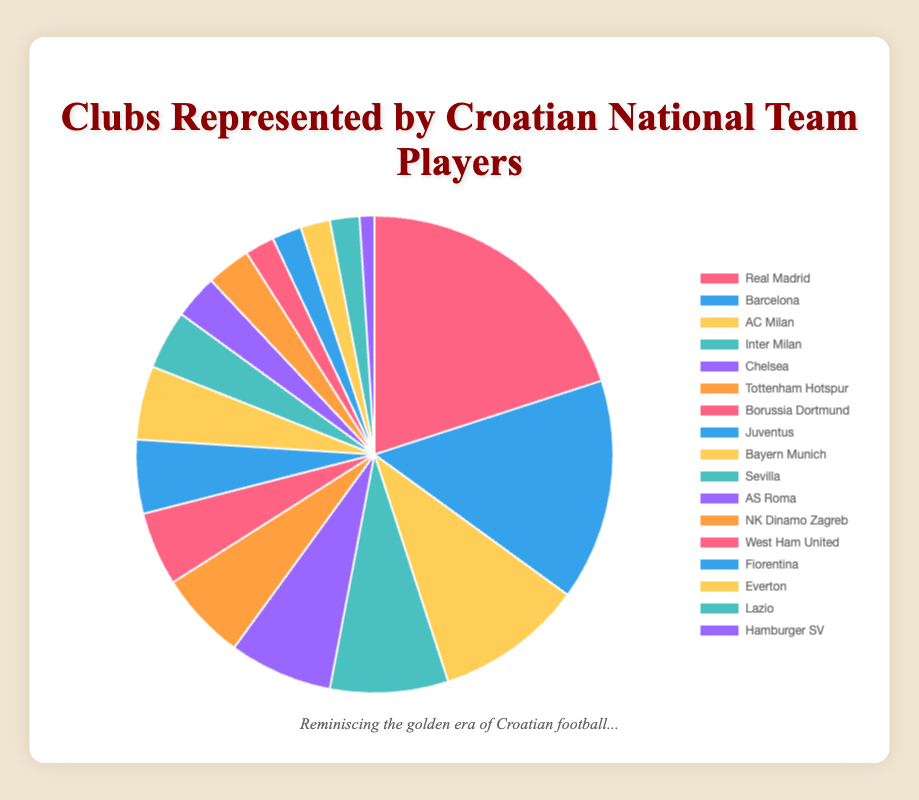Which club has the highest percentage of Croatian national team players during their peak? The pie chart shows that Real Madrid has the highest percentage, with 20%.
Answer: Real Madrid What's the difference in percentage between players who were at Real Madrid and those at Barcelona during their peak? Real Madrid has 20%, and Barcelona has 15%. The difference is 20% - 15% = 5%.
Answer: 5% How many clubs have a representation of 5% or more? The clubs with representation of 5% or more are Real Madrid (20%), Barcelona (15%), AC Milan (10%), Inter Milan (8%), Chelsea (7%), Tottenham Hotspur (6%), Borussia Dortmund (5%), Juventus (5%), and Bayern Munich (5%). There are 9 in total.
Answer: 9 Which clubs have an equal percentage of 5%? Borussia Dortmund, Juventus, and Bayern Munich each have a percentage of 5%.
Answer: Borussia Dortmund, Juventus, Bayern Munich If you combine the percentages of AC Milan and Inter Milan, do they surpass the percentage of Real Madrid? AC Milan has 10%, and Inter Milan has 8%. Combining them gives 10% + 8% = 18%, which is less than 20% from Real Madrid.
Answer: No What is the combined percentage of players from clubs located in Milan (AC Milan and Inter Milan)? AC Milan has 10% and Inter Milan has 8%. The combined percentage is 10% + 8% = 18%.
Answer: 18% How does the representation of players at NK Dinamo Zagreb compare to that of Sevilla? NK Dinamo Zagreb and Sevilla have a similar representation, with NK Dinamo Zagreb at 3% and Sevilla at 4%. Sevilla has slightly more at 1% higher.
Answer: Sevilla has 1% more Which clubs have a representation under 3%, and can you list them? The clubs with a representation under 3% are West Ham United, Fiorentina, Everton, Lazio, and Hamburger SV.
Answer: West Ham United, Fiorentina, Everton, Lazio, Hamburger SV How does the combined representation of Premier League clubs (Chelsea, Tottenham Hotspur, West Ham United, Everton) compare to that of La Liga clubs (Real Madrid, Barcelona, Sevilla)? The Premier League clubs have combined percentages of 7% (Chelsea) + 6% (Tottenham Hotspur) + 2% (West Ham United) + 2% (Everton) = 17%. La Liga clubs have 20% (Real Madrid) + 15% (Barcelona) + 4% (Sevilla) = 39%. La Liga clubs have a higher combined percentage.
Answer: La Liga clubs have more What is the total percentage of clubs from Italy (Serie A) in the chart? The clubs from Italy are AC Milan (10%), Inter Milan (8%), Juventus (5%), AS Roma (3%), Fiorentina (2%), and Lazio (2%). The total percentage is 10% + 8% + 5% + 3% + 2% + 2% = 30%.
Answer: 30% 